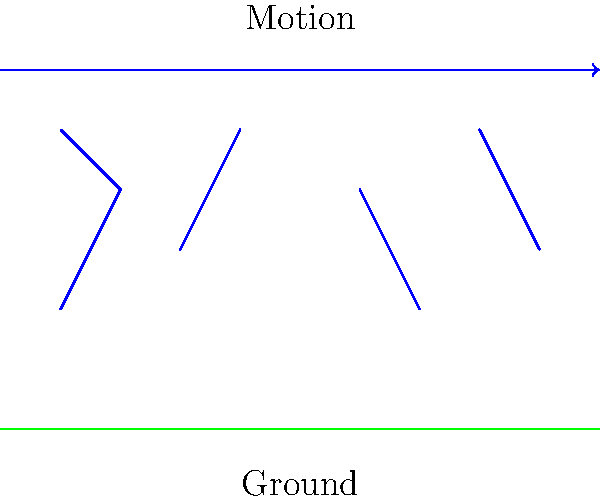In the diagram, a deer is shown running through the forest. During its locomotion, which phase of the deer's gait cycle would generate the maximum ground reaction force, and why? To answer this question, let's break down the deer's gait cycle and the forces involved:

1. The deer's gait cycle can be divided into two main phases: stance phase and swing phase.

2. The stance phase is when the leg is in contact with the ground, while the swing phase is when the leg is off the ground.

3. During running, there's a period called the "double float" where all legs are off the ground.

4. The maximum ground reaction force occurs during the stance phase, specifically at the beginning of the stance phase.

5. This is because:
   a) The deer's body is decelerating vertically as it lands.
   b) The leg muscles are actively contracting to support the body weight and prepare for the next push-off.

6. The force is highest at this point due to the combination of:
   - The deer's body weight
   - The downward momentum from the previous airborne phase
   - The active force production by the leg muscles

7. This high force is necessary to:
   - Arrest the downward motion of the body
   - Store elastic energy in tendons and muscles for the subsequent push-off

8. After this initial peak, the force typically decreases as the leg continues through the stance phase, reaching another smaller peak during push-off.

Therefore, the maximum ground reaction force would occur at the beginning of the stance phase, when the deer's leg first contacts the ground after the airborne phase.
Answer: Beginning of stance phase 